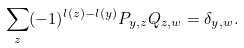Convert formula to latex. <formula><loc_0><loc_0><loc_500><loc_500>\sum _ { z } ( - 1 ) ^ { l ( z ) - l ( y ) } P _ { y , z } Q _ { z , w } = \delta _ { y , w } .</formula> 